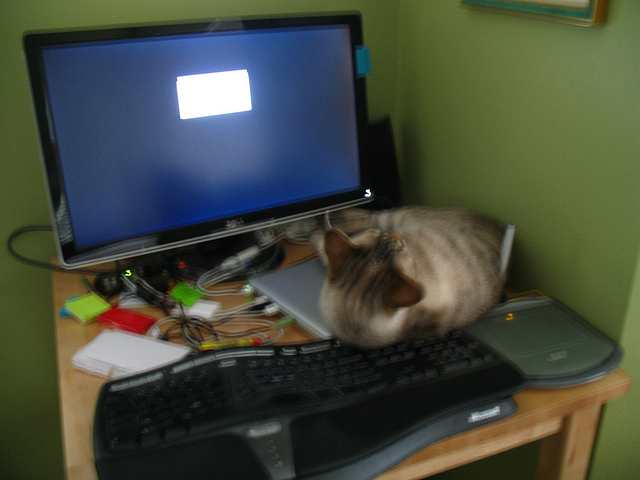<image>What is that green thing laying on desk? I don't know what the green thing laying on the desk is. It could be a paper, mouse pad, cat, pencil sharpener, sticky notes, notepad, sticky, or notecards. What is that green thing laying on desk? I am not sure what that green thing laying on the desk is. It can be seen as 'paper', 'mouse pad', 'cat', 'pencil sharpener', 'sticky notes', 'notepad', 'sticky', 'paper', or 'notecards'. 